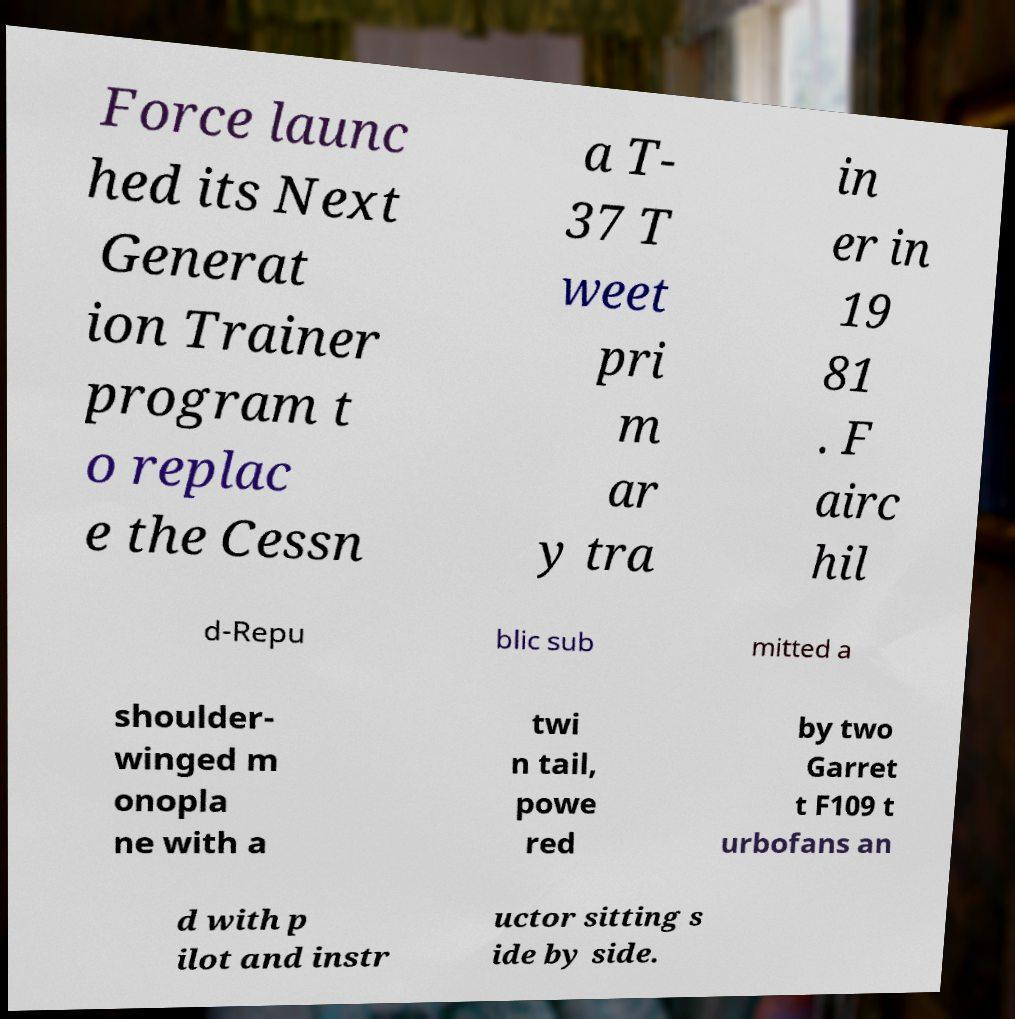Can you accurately transcribe the text from the provided image for me? Force launc hed its Next Generat ion Trainer program t o replac e the Cessn a T- 37 T weet pri m ar y tra in er in 19 81 . F airc hil d-Repu blic sub mitted a shoulder- winged m onopla ne with a twi n tail, powe red by two Garret t F109 t urbofans an d with p ilot and instr uctor sitting s ide by side. 